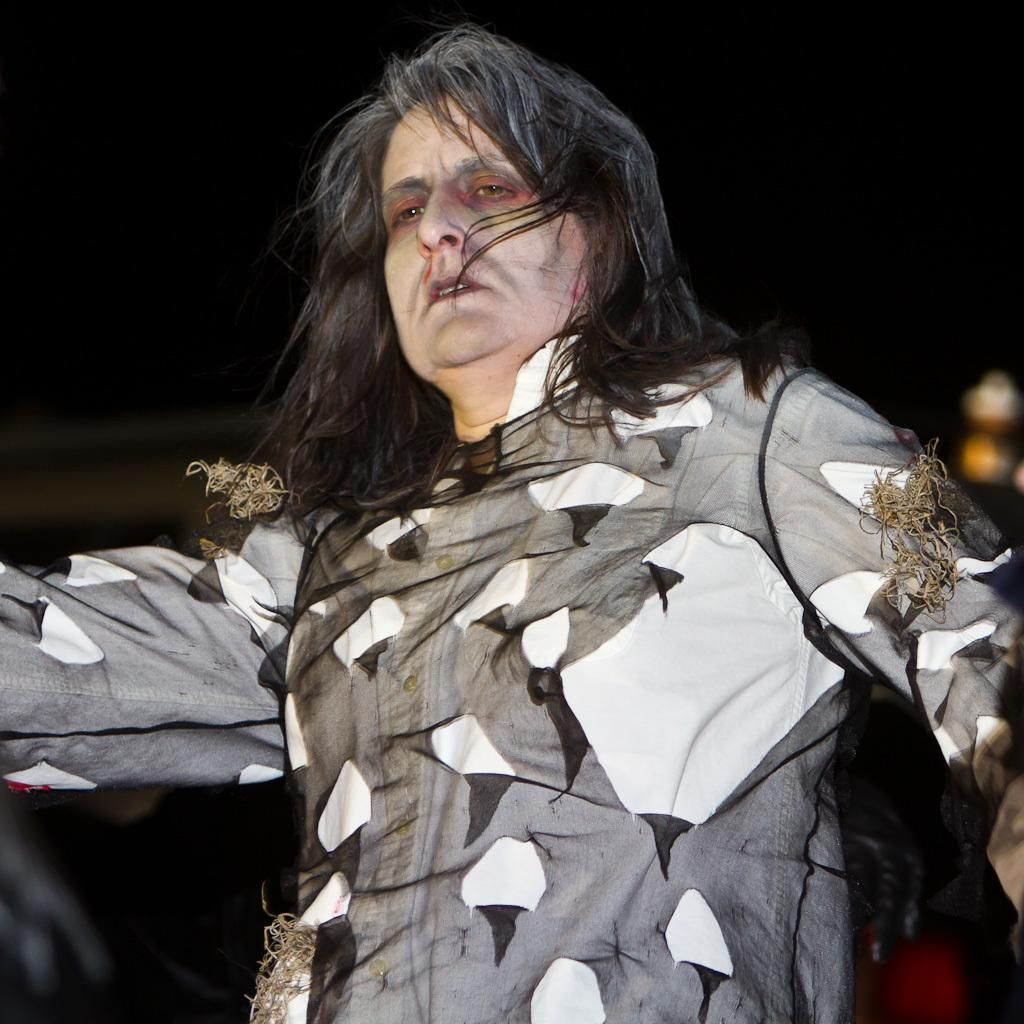What is the main subject of the image? There is a person in the image. What is the person doing in the image? The person is standing. What can be observed about the person's attire in the image? The person is wearing clothes. What type of plants can be seen learning in the image? There are no plants or learning depicted in the image; it features a person standing. What is the mass of the person in the image? The mass of the person cannot be determined from the image alone. 